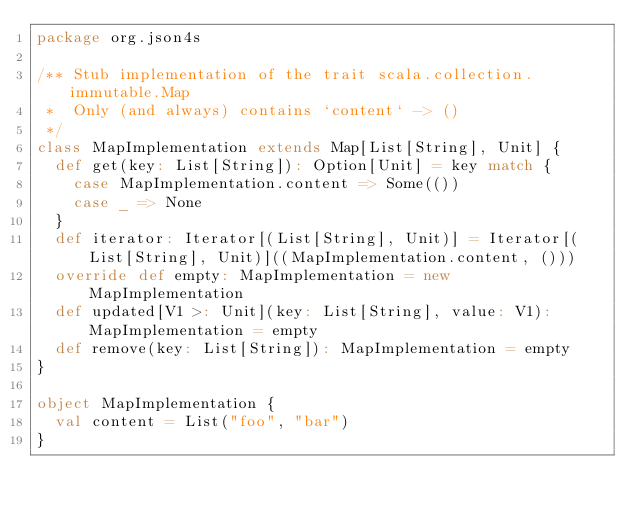<code> <loc_0><loc_0><loc_500><loc_500><_Scala_>package org.json4s

/** Stub implementation of the trait scala.collection.immutable.Map
 *  Only (and always) contains `content` -> ()
 */
class MapImplementation extends Map[List[String], Unit] {
  def get(key: List[String]): Option[Unit] = key match {
    case MapImplementation.content => Some(())
    case _ => None
  }
  def iterator: Iterator[(List[String], Unit)] = Iterator[(List[String], Unit)]((MapImplementation.content, ()))
  override def empty: MapImplementation = new MapImplementation
  def updated[V1 >: Unit](key: List[String], value: V1): MapImplementation = empty
  def remove(key: List[String]): MapImplementation = empty
}

object MapImplementation {
  val content = List("foo", "bar")
}
</code> 